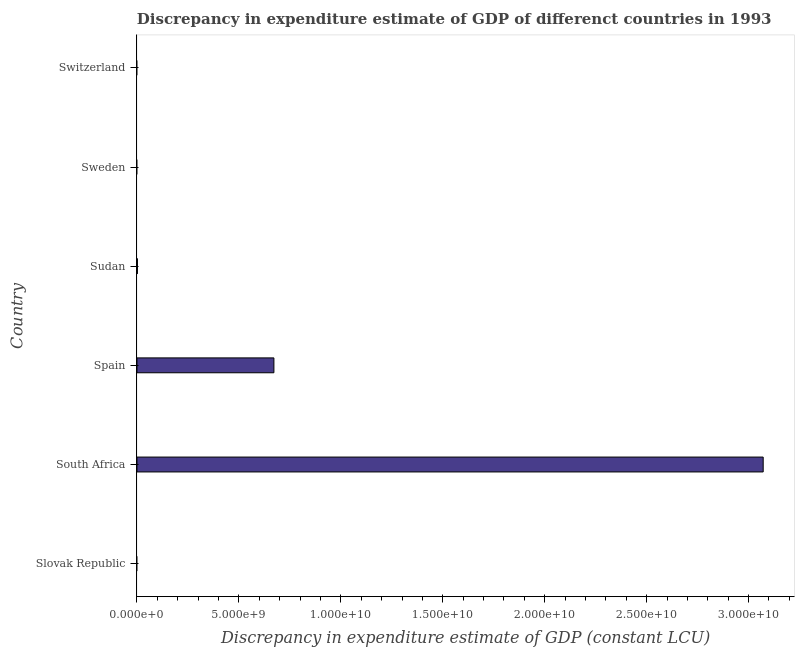Does the graph contain grids?
Keep it short and to the point. No. What is the title of the graph?
Your answer should be very brief. Discrepancy in expenditure estimate of GDP of differenct countries in 1993. What is the label or title of the X-axis?
Offer a terse response. Discrepancy in expenditure estimate of GDP (constant LCU). What is the label or title of the Y-axis?
Make the answer very short. Country. What is the discrepancy in expenditure estimate of gdp in Slovak Republic?
Give a very brief answer. 0. Across all countries, what is the maximum discrepancy in expenditure estimate of gdp?
Provide a short and direct response. 3.07e+1. Across all countries, what is the minimum discrepancy in expenditure estimate of gdp?
Make the answer very short. 0. In which country was the discrepancy in expenditure estimate of gdp maximum?
Offer a very short reply. South Africa. What is the sum of the discrepancy in expenditure estimate of gdp?
Make the answer very short. 3.75e+1. What is the average discrepancy in expenditure estimate of gdp per country?
Provide a short and direct response. 6.24e+09. What is the median discrepancy in expenditure estimate of gdp?
Offer a very short reply. 1.12e+07. In how many countries, is the discrepancy in expenditure estimate of gdp greater than 17000000000 LCU?
Keep it short and to the point. 1. What is the ratio of the discrepancy in expenditure estimate of gdp in Spain to that in Sudan?
Make the answer very short. 299.17. What is the difference between the highest and the second highest discrepancy in expenditure estimate of gdp?
Give a very brief answer. 2.40e+1. What is the difference between the highest and the lowest discrepancy in expenditure estimate of gdp?
Give a very brief answer. 3.07e+1. In how many countries, is the discrepancy in expenditure estimate of gdp greater than the average discrepancy in expenditure estimate of gdp taken over all countries?
Make the answer very short. 2. What is the Discrepancy in expenditure estimate of GDP (constant LCU) of South Africa?
Provide a succinct answer. 3.07e+1. What is the Discrepancy in expenditure estimate of GDP (constant LCU) of Spain?
Keep it short and to the point. 6.72e+09. What is the Discrepancy in expenditure estimate of GDP (constant LCU) in Sudan?
Provide a short and direct response. 2.25e+07. What is the Discrepancy in expenditure estimate of GDP (constant LCU) in Sweden?
Ensure brevity in your answer.  0. What is the Discrepancy in expenditure estimate of GDP (constant LCU) in Switzerland?
Provide a short and direct response. 0. What is the difference between the Discrepancy in expenditure estimate of GDP (constant LCU) in South Africa and Spain?
Your answer should be compact. 2.40e+1. What is the difference between the Discrepancy in expenditure estimate of GDP (constant LCU) in South Africa and Sudan?
Your answer should be very brief. 3.07e+1. What is the difference between the Discrepancy in expenditure estimate of GDP (constant LCU) in Spain and Sudan?
Provide a short and direct response. 6.69e+09. What is the ratio of the Discrepancy in expenditure estimate of GDP (constant LCU) in South Africa to that in Spain?
Offer a terse response. 4.57. What is the ratio of the Discrepancy in expenditure estimate of GDP (constant LCU) in South Africa to that in Sudan?
Your answer should be very brief. 1368.05. What is the ratio of the Discrepancy in expenditure estimate of GDP (constant LCU) in Spain to that in Sudan?
Provide a short and direct response. 299.17. 